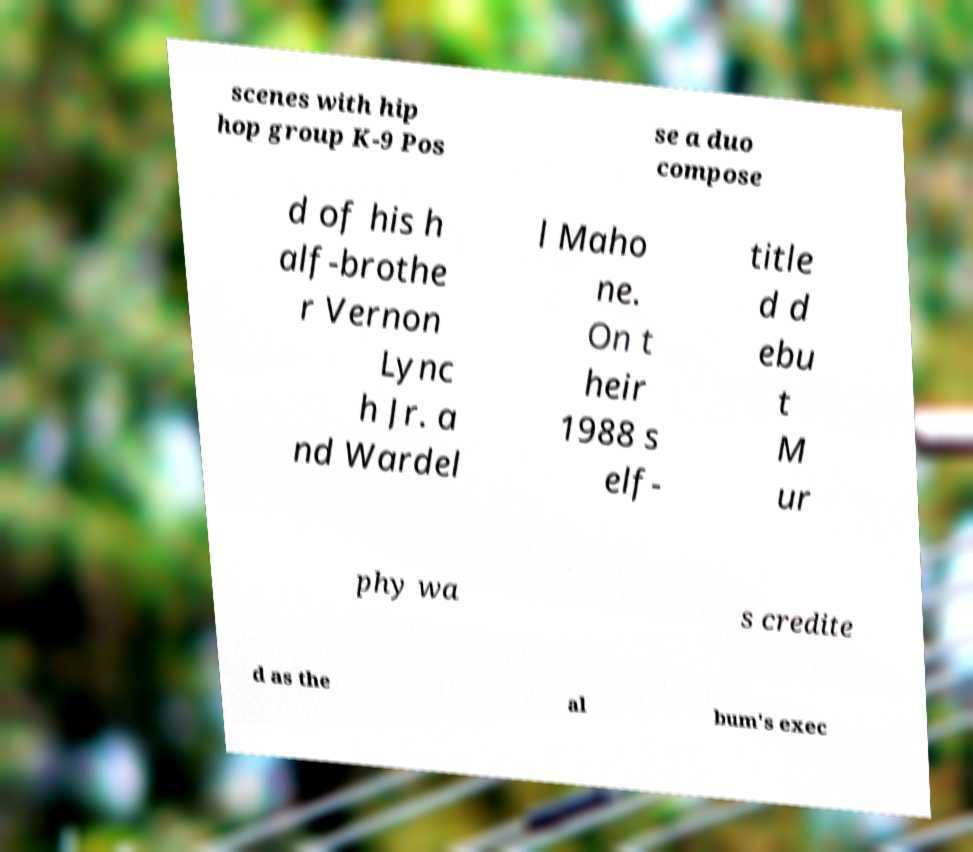Could you assist in decoding the text presented in this image and type it out clearly? scenes with hip hop group K-9 Pos se a duo compose d of his h alf-brothe r Vernon Lync h Jr. a nd Wardel l Maho ne. On t heir 1988 s elf- title d d ebu t M ur phy wa s credite d as the al bum's exec 